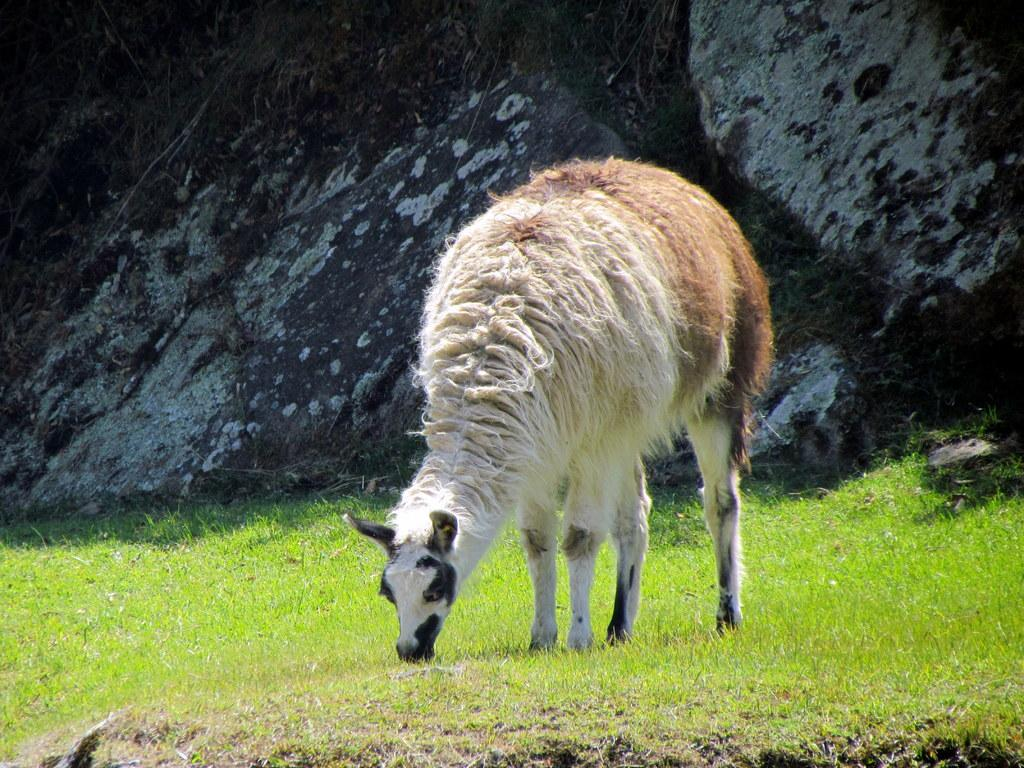What type of animal is present in the image? There is an animal in the image, but its specific type cannot be determined from the provided facts. Where is the animal located in the image? The animal is on the surface of the grass in the image. What can be seen in the distance in the image? There is a mountain visible in the background of the image. What is your uncle's throat doing in the image? There is no mention of an uncle or a throat in the image, so this question cannot be answered. 